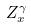Convert formula to latex. <formula><loc_0><loc_0><loc_500><loc_500>Z _ { x } ^ { \gamma }</formula> 